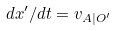Convert formula to latex. <formula><loc_0><loc_0><loc_500><loc_500>d x ^ { \prime } / d t = v _ { A | O ^ { \prime } }</formula> 